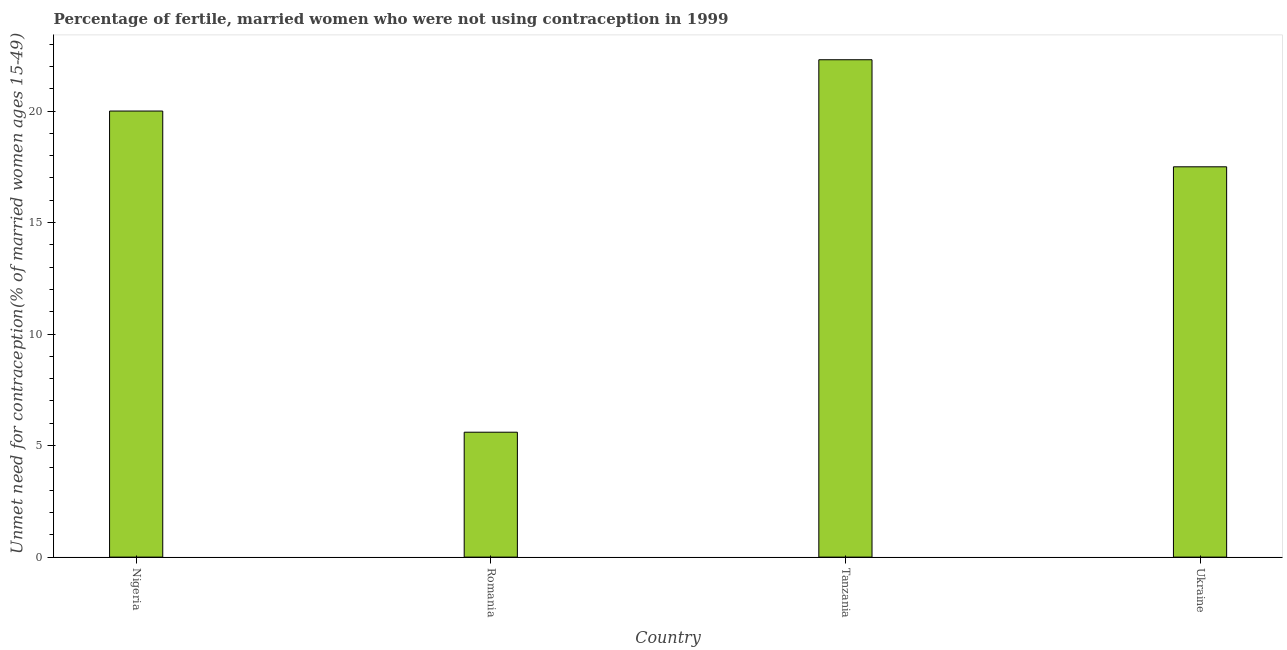Does the graph contain any zero values?
Keep it short and to the point. No. What is the title of the graph?
Your answer should be compact. Percentage of fertile, married women who were not using contraception in 1999. What is the label or title of the X-axis?
Make the answer very short. Country. What is the label or title of the Y-axis?
Give a very brief answer.  Unmet need for contraception(% of married women ages 15-49). What is the number of married women who are not using contraception in Ukraine?
Keep it short and to the point. 17.5. Across all countries, what is the maximum number of married women who are not using contraception?
Provide a succinct answer. 22.3. In which country was the number of married women who are not using contraception maximum?
Keep it short and to the point. Tanzania. In which country was the number of married women who are not using contraception minimum?
Keep it short and to the point. Romania. What is the sum of the number of married women who are not using contraception?
Make the answer very short. 65.4. What is the average number of married women who are not using contraception per country?
Your answer should be compact. 16.35. What is the median number of married women who are not using contraception?
Offer a very short reply. 18.75. What is the ratio of the number of married women who are not using contraception in Tanzania to that in Ukraine?
Provide a short and direct response. 1.27. Is the number of married women who are not using contraception in Romania less than that in Tanzania?
Ensure brevity in your answer.  Yes. Is the sum of the number of married women who are not using contraception in Tanzania and Ukraine greater than the maximum number of married women who are not using contraception across all countries?
Provide a succinct answer. Yes. In how many countries, is the number of married women who are not using contraception greater than the average number of married women who are not using contraception taken over all countries?
Offer a very short reply. 3. Are all the bars in the graph horizontal?
Offer a very short reply. No. How many countries are there in the graph?
Keep it short and to the point. 4. Are the values on the major ticks of Y-axis written in scientific E-notation?
Ensure brevity in your answer.  No. What is the  Unmet need for contraception(% of married women ages 15-49) of Nigeria?
Provide a succinct answer. 20. What is the  Unmet need for contraception(% of married women ages 15-49) in Tanzania?
Offer a terse response. 22.3. What is the difference between the  Unmet need for contraception(% of married women ages 15-49) in Nigeria and Ukraine?
Ensure brevity in your answer.  2.5. What is the difference between the  Unmet need for contraception(% of married women ages 15-49) in Romania and Tanzania?
Your answer should be compact. -16.7. What is the ratio of the  Unmet need for contraception(% of married women ages 15-49) in Nigeria to that in Romania?
Offer a very short reply. 3.57. What is the ratio of the  Unmet need for contraception(% of married women ages 15-49) in Nigeria to that in Tanzania?
Make the answer very short. 0.9. What is the ratio of the  Unmet need for contraception(% of married women ages 15-49) in Nigeria to that in Ukraine?
Offer a terse response. 1.14. What is the ratio of the  Unmet need for contraception(% of married women ages 15-49) in Romania to that in Tanzania?
Offer a very short reply. 0.25. What is the ratio of the  Unmet need for contraception(% of married women ages 15-49) in Romania to that in Ukraine?
Your answer should be compact. 0.32. What is the ratio of the  Unmet need for contraception(% of married women ages 15-49) in Tanzania to that in Ukraine?
Your answer should be very brief. 1.27. 